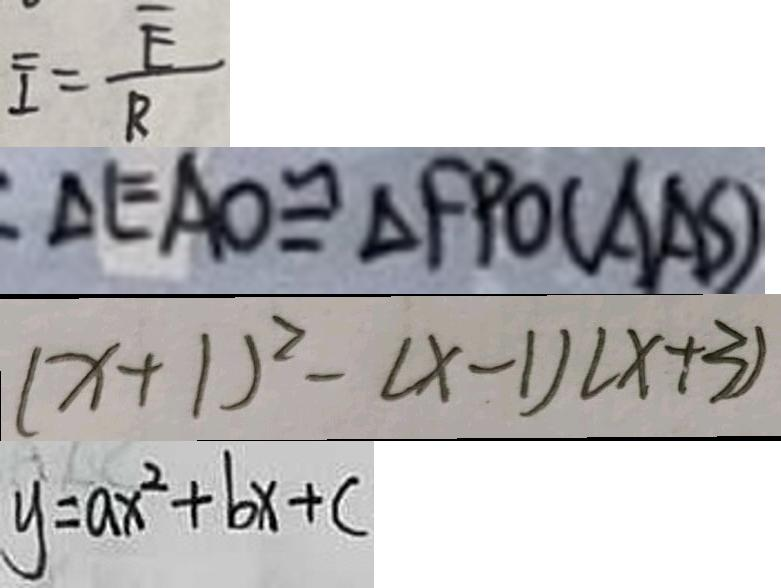<formula> <loc_0><loc_0><loc_500><loc_500>\overline { I } = \frac { \overline { E } } { R } 
 \Delta E A O \cong \Delta F P O ( A A S ) 
 ( x + 1 ) ^ { 2 } - ( x - 1 ) ( x + 3 ) 
 y = a x ^ { 2 } + b x + c</formula> 